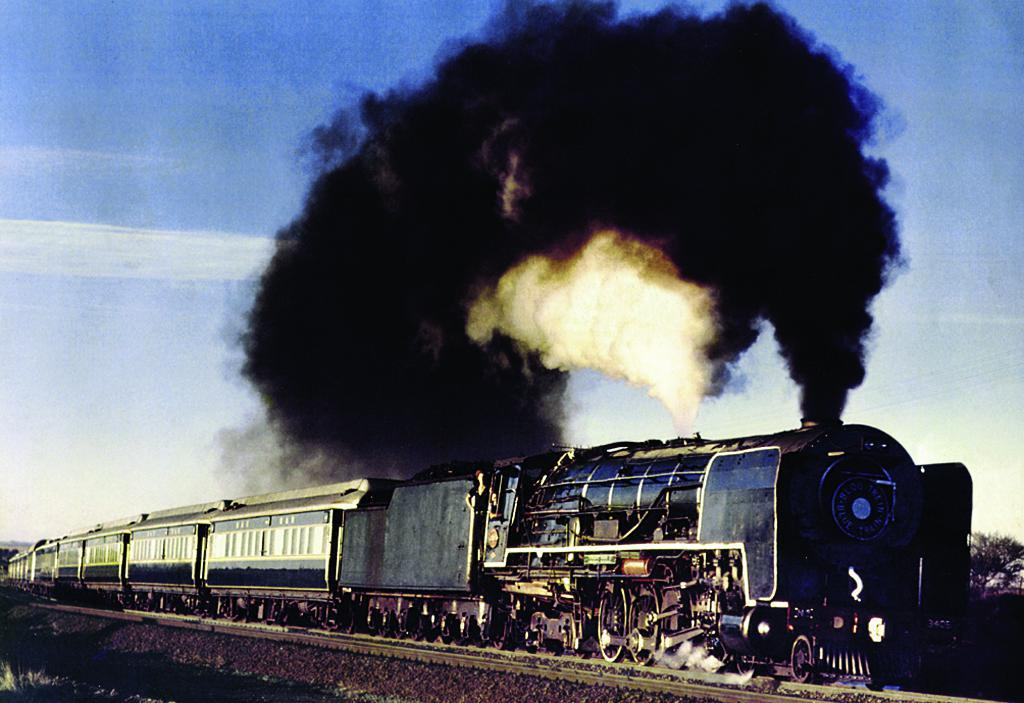What type of vehicle is in the image? There is a blue color train in the image. What is the train doing in the image? The train is running on a track. What can be seen coming out of the train in the image? Thick black smoke is visible in the image. What is the condition of the sky in the image? The sky is blue and clear in the image. How many girls are working on the train in the image? There are no girls present in the image, and the train is not a workplace. 